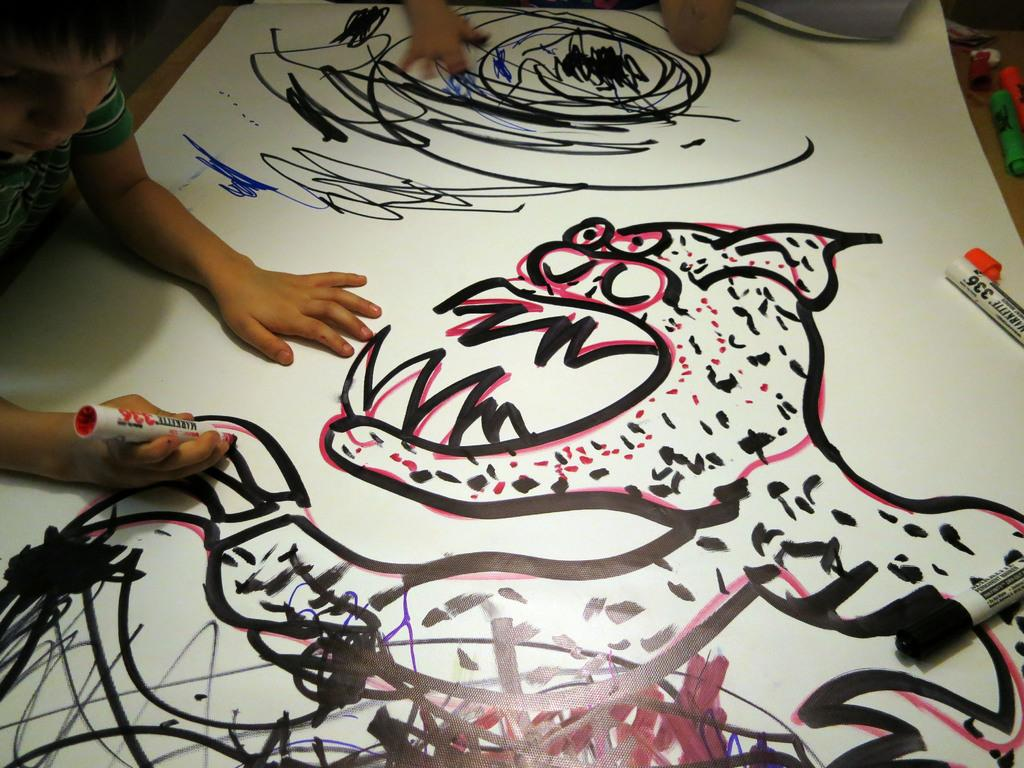What is the main subject of the image? The main subject of the image is a chart. What else can be seen in the image besides the chart? There is a drawing done by a boy and some sketches in the image. What type of wax can be seen melting in the image? There is no wax present in the image; it features a chart, a drawing done by a boy, and some sketches. 